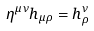Convert formula to latex. <formula><loc_0><loc_0><loc_500><loc_500>\eta ^ { \mu \nu } h _ { \mu \rho } = h ^ { \nu } _ { \rho }</formula> 